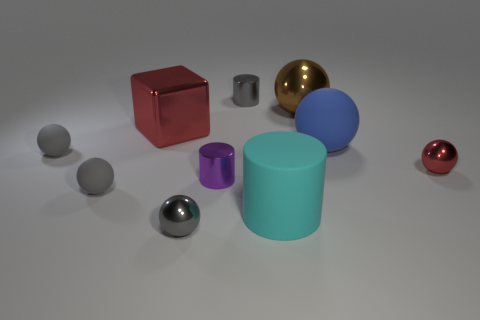Subtract all cyan cubes. How many gray balls are left? 3 Subtract all red shiny spheres. How many spheres are left? 5 Subtract all brown balls. How many balls are left? 5 Subtract all cyan spheres. Subtract all cyan cylinders. How many spheres are left? 6 Subtract all balls. How many objects are left? 4 Add 8 small matte spheres. How many small matte spheres exist? 10 Subtract 0 green cubes. How many objects are left? 10 Subtract all small purple shiny balls. Subtract all gray matte things. How many objects are left? 8 Add 3 cyan cylinders. How many cyan cylinders are left? 4 